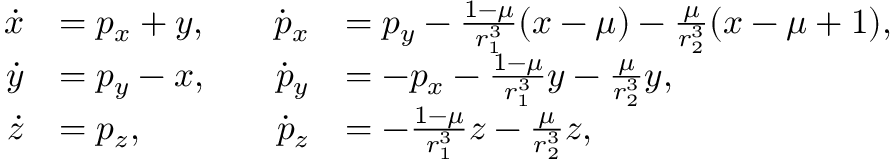Convert formula to latex. <formula><loc_0><loc_0><loc_500><loc_500>\begin{array} { r l r l } { \dot { x } } & { = p _ { x } + y , \quad } & { \dot { p } _ { x } } & { = p _ { y } - \frac { 1 - \mu } { r _ { 1 } ^ { 3 } } ( x - \mu ) - \frac { \mu } { r _ { 2 } ^ { 3 } } ( x - \mu + 1 ) , } \\ { \dot { y } } & { = p _ { y } - x , \quad } & { \dot { p } _ { y } } & { = - p _ { x } - \frac { 1 - \mu } { r _ { 1 } ^ { 3 } } y - \frac { \mu } { r _ { 2 } ^ { 3 } } y , } \\ { \dot { z } } & { = p _ { z } , \quad } & { \dot { p } _ { z } } & { = - \frac { 1 - \mu } { r _ { 1 } ^ { 3 } } z - \frac { \mu } { r _ { 2 } ^ { 3 } } z , } \end{array}</formula> 